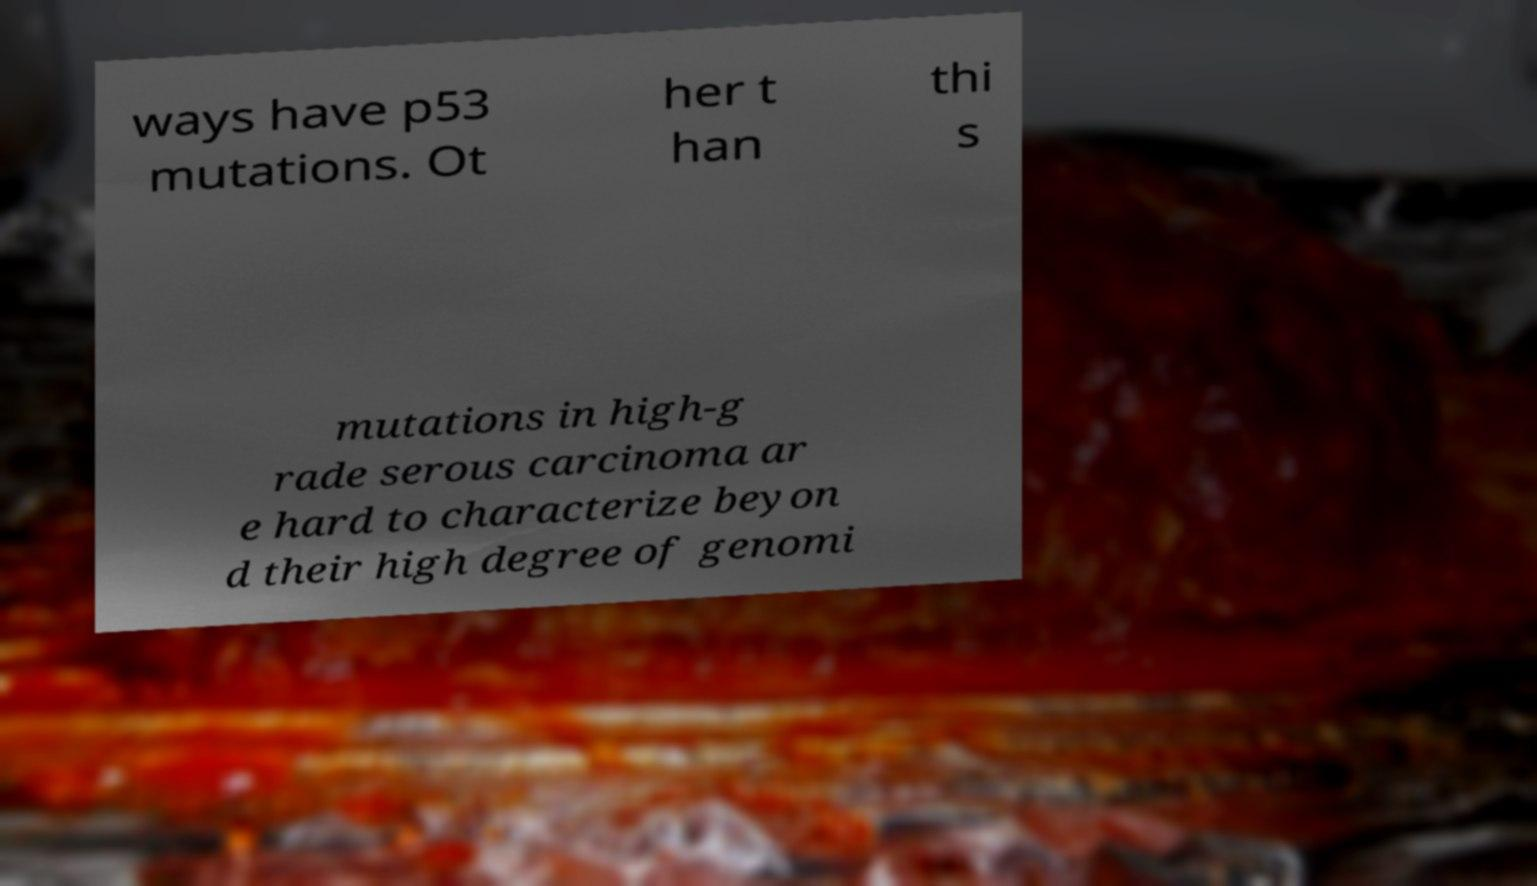What messages or text are displayed in this image? I need them in a readable, typed format. ways have p53 mutations. Ot her t han thi s mutations in high-g rade serous carcinoma ar e hard to characterize beyon d their high degree of genomi 